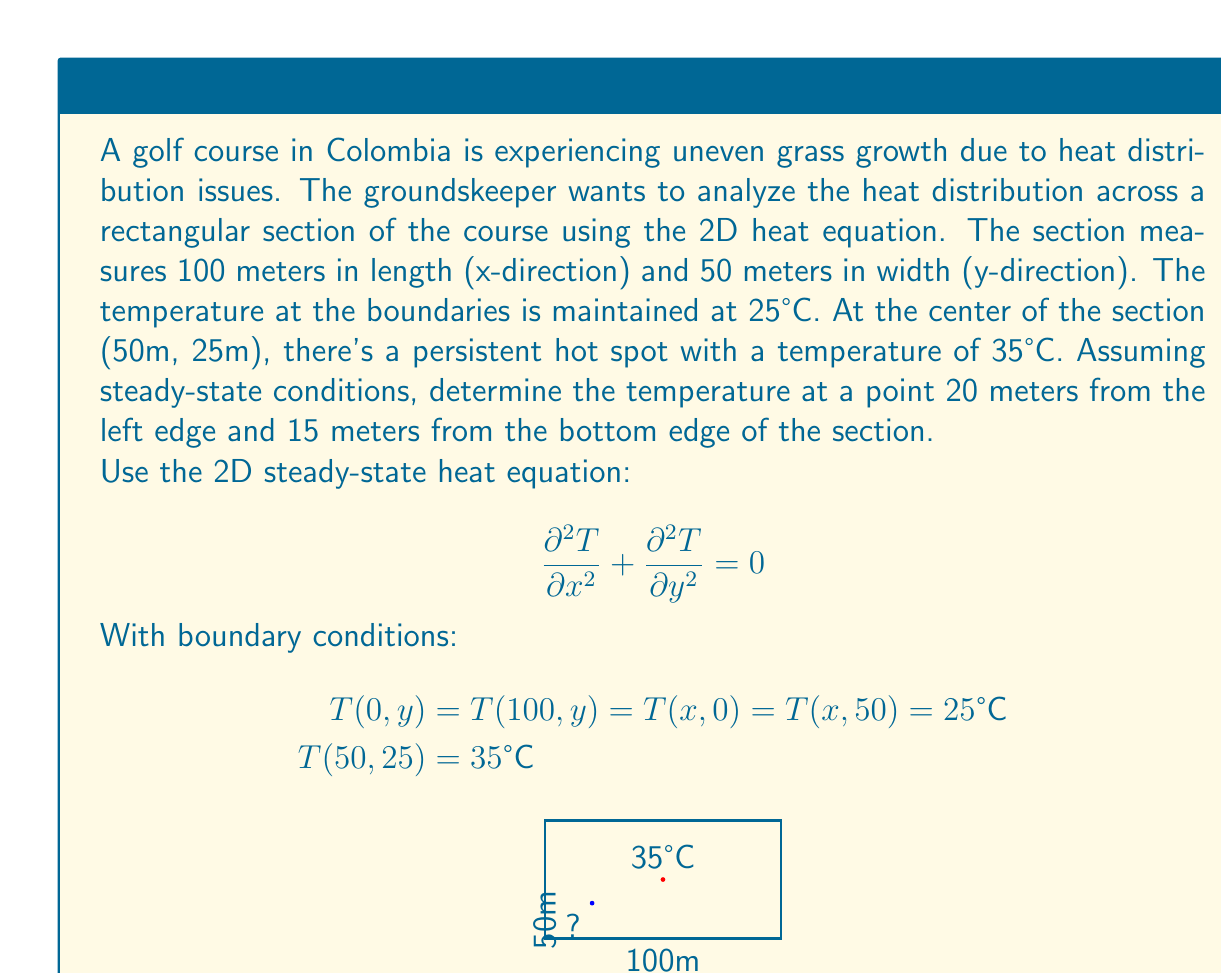Show me your answer to this math problem. To solve this problem, we'll use the method of separation of variables for the 2D steady-state heat equation.

1) Assume the solution has the form: $T(x,y) = X(x)Y(y)$

2) Substituting into the heat equation:
   $$ X''(x)Y(y) + X(x)Y''(y) = 0 $$
   $$ \frac{X''(x)}{X(x)} = -\frac{Y''(y)}{Y(y)} = -\lambda^2 $$

3) This leads to two ODEs:
   $X''(x) + \lambda^2 X(x) = 0$
   $Y''(y) + \lambda^2 Y(y) = 0$

4) The general solutions are:
   $X(x) = A \cos(\lambda x) + B \sin(\lambda x)$
   $Y(y) = C \cos(\lambda y) + D \sin(\lambda y)$

5) Applying the boundary conditions:
   $T(0,y) = T(100,y) = 25°C$ implies $\lambda_n = \frac{n\pi}{100}$, where n is an integer.
   $T(x,0) = T(x,50) = 25°C$ implies $\lambda_m = \frac{m\pi}{50}$, where m is an integer.

6) The general solution becomes:
   $$ T(x,y) = 25 + \sum_{n=1}^{\infty}\sum_{m=1}^{\infty} A_{nm} \sin(\frac{n\pi x}{100}) \sin(\frac{m\pi y}{50}) $$

7) To determine $A_{nm}$, we use the condition $T(50,25) = 35°C$:
   $$ 35 = 25 + \sum_{n=1}^{\infty}\sum_{m=1}^{\infty} A_{nm} \sin(\frac{n\pi}{2}) \sin(\frac{m\pi}{2}) $$

8) This is a complex Fourier series. In practice, we would truncate the series and solve numerically for $A_{nm}$.

9) For an approximation, we can use the first term of the series:
   $$ T(x,y) \approx 25 + 10 \sin(\frac{\pi x}{100}) \sin(\frac{\pi y}{50}) $$

10) At the point (20m, 15m):
    $$ T(20,15) \approx 25 + 10 \sin(\frac{\pi \cdot 20}{100}) \sin(\frac{\pi \cdot 15}{50}) $$
    $$ T(20,15) \approx 25 + 10 \cdot 0.5878 \cdot 0.8090 \approx 29.75°C $$
Answer: The approximate temperature at the point 20 meters from the left edge and 15 meters from the bottom edge of the section is 29.75°C. 